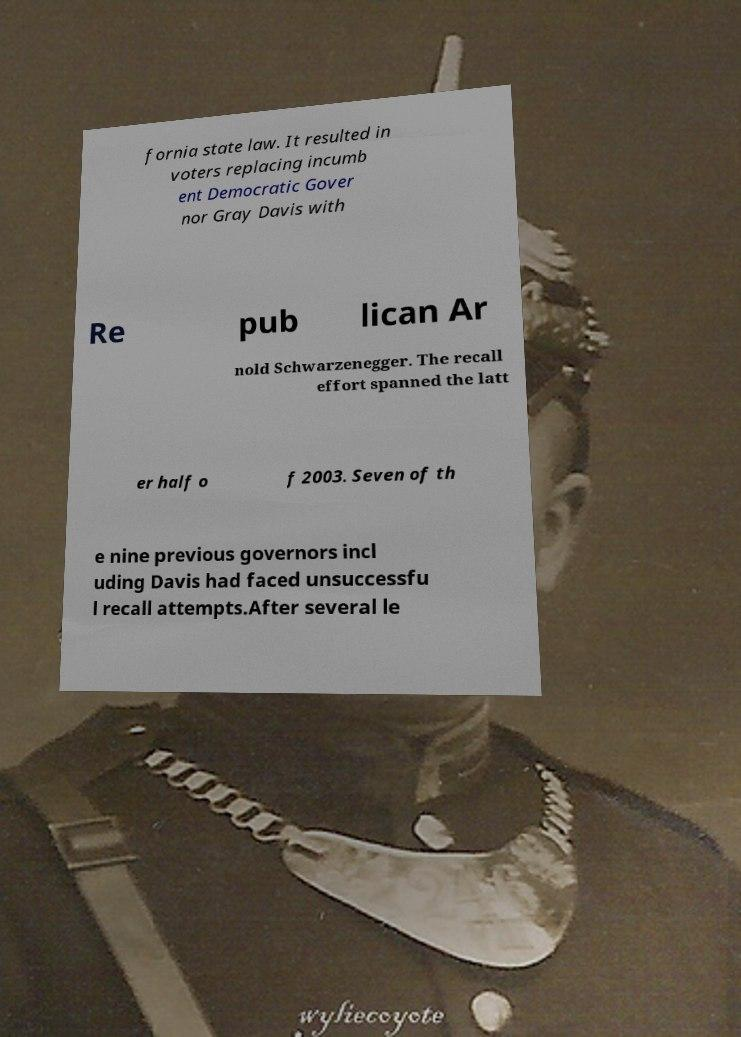Could you assist in decoding the text presented in this image and type it out clearly? fornia state law. It resulted in voters replacing incumb ent Democratic Gover nor Gray Davis with Re pub lican Ar nold Schwarzenegger. The recall effort spanned the latt er half o f 2003. Seven of th e nine previous governors incl uding Davis had faced unsuccessfu l recall attempts.After several le 